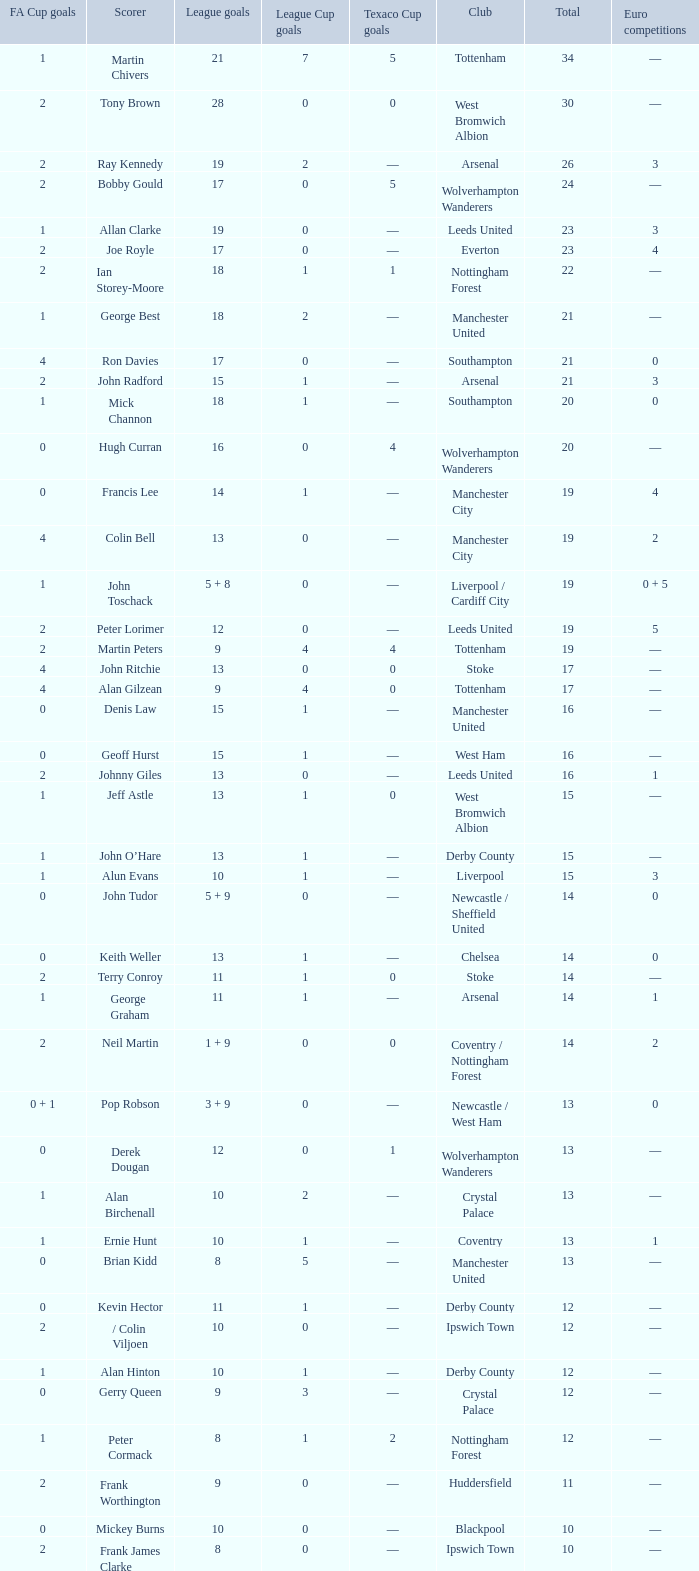What is the lowest League Cup Goals, when Scorer is Denis Law? 1.0. 